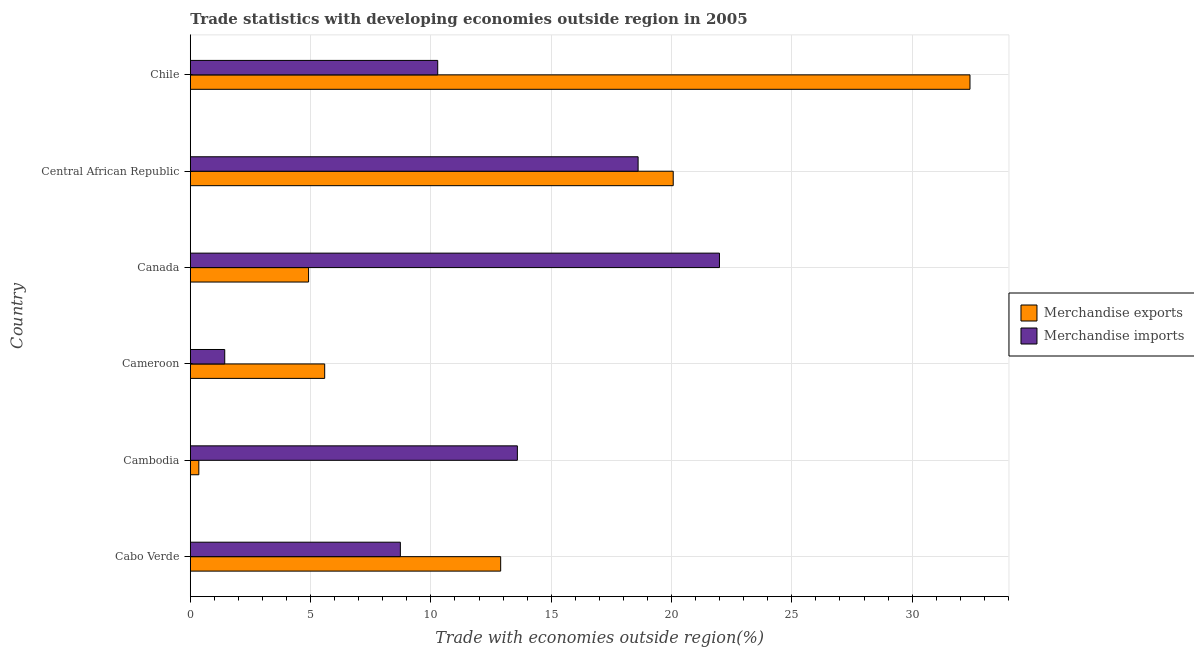How many different coloured bars are there?
Offer a very short reply. 2. How many groups of bars are there?
Offer a very short reply. 6. Are the number of bars per tick equal to the number of legend labels?
Ensure brevity in your answer.  Yes. Are the number of bars on each tick of the Y-axis equal?
Make the answer very short. Yes. How many bars are there on the 3rd tick from the top?
Offer a very short reply. 2. How many bars are there on the 4th tick from the bottom?
Provide a succinct answer. 2. What is the label of the 6th group of bars from the top?
Your response must be concise. Cabo Verde. What is the merchandise exports in Canada?
Offer a very short reply. 4.92. Across all countries, what is the maximum merchandise exports?
Provide a short and direct response. 32.4. Across all countries, what is the minimum merchandise exports?
Provide a short and direct response. 0.35. In which country was the merchandise imports maximum?
Offer a very short reply. Canada. In which country was the merchandise imports minimum?
Provide a succinct answer. Cameroon. What is the total merchandise imports in the graph?
Keep it short and to the point. 74.64. What is the difference between the merchandise exports in Cameroon and that in Chile?
Provide a short and direct response. -26.82. What is the difference between the merchandise imports in Canada and the merchandise exports in Cabo Verde?
Provide a succinct answer. 9.09. What is the average merchandise exports per country?
Provide a short and direct response. 12.7. What is the difference between the merchandise imports and merchandise exports in Canada?
Provide a short and direct response. 17.07. What is the ratio of the merchandise exports in Cambodia to that in Canada?
Your answer should be compact. 0.07. Is the merchandise imports in Canada less than that in Chile?
Ensure brevity in your answer.  No. What is the difference between the highest and the second highest merchandise imports?
Your answer should be compact. 3.38. What is the difference between the highest and the lowest merchandise exports?
Offer a very short reply. 32.05. In how many countries, is the merchandise imports greater than the average merchandise imports taken over all countries?
Ensure brevity in your answer.  3. What does the 1st bar from the bottom in Cambodia represents?
Ensure brevity in your answer.  Merchandise exports. Are all the bars in the graph horizontal?
Give a very brief answer. Yes. How many countries are there in the graph?
Your response must be concise. 6. Are the values on the major ticks of X-axis written in scientific E-notation?
Offer a very short reply. No. Does the graph contain any zero values?
Provide a short and direct response. No. How are the legend labels stacked?
Your answer should be very brief. Vertical. What is the title of the graph?
Offer a very short reply. Trade statistics with developing economies outside region in 2005. Does "Male population" appear as one of the legend labels in the graph?
Your answer should be very brief. No. What is the label or title of the X-axis?
Your answer should be compact. Trade with economies outside region(%). What is the Trade with economies outside region(%) of Merchandise exports in Cabo Verde?
Give a very brief answer. 12.9. What is the Trade with economies outside region(%) in Merchandise imports in Cabo Verde?
Your answer should be very brief. 8.73. What is the Trade with economies outside region(%) of Merchandise exports in Cambodia?
Your answer should be very brief. 0.35. What is the Trade with economies outside region(%) of Merchandise imports in Cambodia?
Offer a terse response. 13.59. What is the Trade with economies outside region(%) in Merchandise exports in Cameroon?
Your answer should be compact. 5.59. What is the Trade with economies outside region(%) in Merchandise imports in Cameroon?
Offer a very short reply. 1.43. What is the Trade with economies outside region(%) in Merchandise exports in Canada?
Ensure brevity in your answer.  4.92. What is the Trade with economies outside region(%) of Merchandise imports in Canada?
Ensure brevity in your answer.  21.99. What is the Trade with economies outside region(%) in Merchandise exports in Central African Republic?
Your answer should be very brief. 20.07. What is the Trade with economies outside region(%) in Merchandise imports in Central African Republic?
Your response must be concise. 18.61. What is the Trade with economies outside region(%) of Merchandise exports in Chile?
Your response must be concise. 32.4. What is the Trade with economies outside region(%) in Merchandise imports in Chile?
Provide a succinct answer. 10.28. Across all countries, what is the maximum Trade with economies outside region(%) in Merchandise exports?
Offer a terse response. 32.4. Across all countries, what is the maximum Trade with economies outside region(%) of Merchandise imports?
Your answer should be compact. 21.99. Across all countries, what is the minimum Trade with economies outside region(%) of Merchandise exports?
Your response must be concise. 0.35. Across all countries, what is the minimum Trade with economies outside region(%) of Merchandise imports?
Offer a very short reply. 1.43. What is the total Trade with economies outside region(%) of Merchandise exports in the graph?
Offer a very short reply. 76.23. What is the total Trade with economies outside region(%) in Merchandise imports in the graph?
Ensure brevity in your answer.  74.64. What is the difference between the Trade with economies outside region(%) of Merchandise exports in Cabo Verde and that in Cambodia?
Offer a terse response. 12.54. What is the difference between the Trade with economies outside region(%) of Merchandise imports in Cabo Verde and that in Cambodia?
Your answer should be very brief. -4.86. What is the difference between the Trade with economies outside region(%) in Merchandise exports in Cabo Verde and that in Cameroon?
Your answer should be very brief. 7.31. What is the difference between the Trade with economies outside region(%) in Merchandise imports in Cabo Verde and that in Cameroon?
Offer a very short reply. 7.3. What is the difference between the Trade with economies outside region(%) of Merchandise exports in Cabo Verde and that in Canada?
Your answer should be compact. 7.98. What is the difference between the Trade with economies outside region(%) in Merchandise imports in Cabo Verde and that in Canada?
Offer a very short reply. -13.26. What is the difference between the Trade with economies outside region(%) of Merchandise exports in Cabo Verde and that in Central African Republic?
Provide a short and direct response. -7.17. What is the difference between the Trade with economies outside region(%) of Merchandise imports in Cabo Verde and that in Central African Republic?
Your answer should be very brief. -9.88. What is the difference between the Trade with economies outside region(%) in Merchandise exports in Cabo Verde and that in Chile?
Provide a succinct answer. -19.5. What is the difference between the Trade with economies outside region(%) in Merchandise imports in Cabo Verde and that in Chile?
Provide a succinct answer. -1.55. What is the difference between the Trade with economies outside region(%) in Merchandise exports in Cambodia and that in Cameroon?
Offer a very short reply. -5.23. What is the difference between the Trade with economies outside region(%) of Merchandise imports in Cambodia and that in Cameroon?
Your response must be concise. 12.16. What is the difference between the Trade with economies outside region(%) in Merchandise exports in Cambodia and that in Canada?
Give a very brief answer. -4.56. What is the difference between the Trade with economies outside region(%) of Merchandise imports in Cambodia and that in Canada?
Your answer should be compact. -8.4. What is the difference between the Trade with economies outside region(%) in Merchandise exports in Cambodia and that in Central African Republic?
Your answer should be compact. -19.72. What is the difference between the Trade with economies outside region(%) in Merchandise imports in Cambodia and that in Central African Republic?
Offer a very short reply. -5.02. What is the difference between the Trade with economies outside region(%) in Merchandise exports in Cambodia and that in Chile?
Offer a very short reply. -32.05. What is the difference between the Trade with economies outside region(%) of Merchandise imports in Cambodia and that in Chile?
Offer a very short reply. 3.31. What is the difference between the Trade with economies outside region(%) of Merchandise exports in Cameroon and that in Canada?
Offer a terse response. 0.67. What is the difference between the Trade with economies outside region(%) in Merchandise imports in Cameroon and that in Canada?
Your response must be concise. -20.56. What is the difference between the Trade with economies outside region(%) in Merchandise exports in Cameroon and that in Central African Republic?
Make the answer very short. -14.48. What is the difference between the Trade with economies outside region(%) of Merchandise imports in Cameroon and that in Central African Republic?
Offer a terse response. -17.18. What is the difference between the Trade with economies outside region(%) in Merchandise exports in Cameroon and that in Chile?
Keep it short and to the point. -26.82. What is the difference between the Trade with economies outside region(%) of Merchandise imports in Cameroon and that in Chile?
Your response must be concise. -8.85. What is the difference between the Trade with economies outside region(%) of Merchandise exports in Canada and that in Central African Republic?
Keep it short and to the point. -15.15. What is the difference between the Trade with economies outside region(%) in Merchandise imports in Canada and that in Central African Republic?
Offer a very short reply. 3.38. What is the difference between the Trade with economies outside region(%) of Merchandise exports in Canada and that in Chile?
Your response must be concise. -27.49. What is the difference between the Trade with economies outside region(%) of Merchandise imports in Canada and that in Chile?
Your answer should be compact. 11.71. What is the difference between the Trade with economies outside region(%) in Merchandise exports in Central African Republic and that in Chile?
Offer a very short reply. -12.33. What is the difference between the Trade with economies outside region(%) of Merchandise imports in Central African Republic and that in Chile?
Make the answer very short. 8.33. What is the difference between the Trade with economies outside region(%) in Merchandise exports in Cabo Verde and the Trade with economies outside region(%) in Merchandise imports in Cambodia?
Provide a succinct answer. -0.69. What is the difference between the Trade with economies outside region(%) in Merchandise exports in Cabo Verde and the Trade with economies outside region(%) in Merchandise imports in Cameroon?
Your answer should be very brief. 11.47. What is the difference between the Trade with economies outside region(%) in Merchandise exports in Cabo Verde and the Trade with economies outside region(%) in Merchandise imports in Canada?
Ensure brevity in your answer.  -9.09. What is the difference between the Trade with economies outside region(%) of Merchandise exports in Cabo Verde and the Trade with economies outside region(%) of Merchandise imports in Central African Republic?
Make the answer very short. -5.71. What is the difference between the Trade with economies outside region(%) in Merchandise exports in Cabo Verde and the Trade with economies outside region(%) in Merchandise imports in Chile?
Offer a terse response. 2.62. What is the difference between the Trade with economies outside region(%) in Merchandise exports in Cambodia and the Trade with economies outside region(%) in Merchandise imports in Cameroon?
Keep it short and to the point. -1.08. What is the difference between the Trade with economies outside region(%) in Merchandise exports in Cambodia and the Trade with economies outside region(%) in Merchandise imports in Canada?
Your answer should be compact. -21.64. What is the difference between the Trade with economies outside region(%) in Merchandise exports in Cambodia and the Trade with economies outside region(%) in Merchandise imports in Central African Republic?
Provide a succinct answer. -18.26. What is the difference between the Trade with economies outside region(%) of Merchandise exports in Cambodia and the Trade with economies outside region(%) of Merchandise imports in Chile?
Ensure brevity in your answer.  -9.93. What is the difference between the Trade with economies outside region(%) in Merchandise exports in Cameroon and the Trade with economies outside region(%) in Merchandise imports in Canada?
Provide a short and direct response. -16.41. What is the difference between the Trade with economies outside region(%) of Merchandise exports in Cameroon and the Trade with economies outside region(%) of Merchandise imports in Central African Republic?
Keep it short and to the point. -13.03. What is the difference between the Trade with economies outside region(%) in Merchandise exports in Cameroon and the Trade with economies outside region(%) in Merchandise imports in Chile?
Your answer should be compact. -4.7. What is the difference between the Trade with economies outside region(%) in Merchandise exports in Canada and the Trade with economies outside region(%) in Merchandise imports in Central African Republic?
Provide a short and direct response. -13.69. What is the difference between the Trade with economies outside region(%) in Merchandise exports in Canada and the Trade with economies outside region(%) in Merchandise imports in Chile?
Ensure brevity in your answer.  -5.37. What is the difference between the Trade with economies outside region(%) of Merchandise exports in Central African Republic and the Trade with economies outside region(%) of Merchandise imports in Chile?
Offer a very short reply. 9.79. What is the average Trade with economies outside region(%) of Merchandise exports per country?
Your answer should be very brief. 12.7. What is the average Trade with economies outside region(%) of Merchandise imports per country?
Keep it short and to the point. 12.44. What is the difference between the Trade with economies outside region(%) in Merchandise exports and Trade with economies outside region(%) in Merchandise imports in Cabo Verde?
Keep it short and to the point. 4.17. What is the difference between the Trade with economies outside region(%) in Merchandise exports and Trade with economies outside region(%) in Merchandise imports in Cambodia?
Ensure brevity in your answer.  -13.24. What is the difference between the Trade with economies outside region(%) in Merchandise exports and Trade with economies outside region(%) in Merchandise imports in Cameroon?
Your answer should be very brief. 4.15. What is the difference between the Trade with economies outside region(%) in Merchandise exports and Trade with economies outside region(%) in Merchandise imports in Canada?
Offer a terse response. -17.08. What is the difference between the Trade with economies outside region(%) of Merchandise exports and Trade with economies outside region(%) of Merchandise imports in Central African Republic?
Your answer should be very brief. 1.46. What is the difference between the Trade with economies outside region(%) of Merchandise exports and Trade with economies outside region(%) of Merchandise imports in Chile?
Your answer should be compact. 22.12. What is the ratio of the Trade with economies outside region(%) of Merchandise exports in Cabo Verde to that in Cambodia?
Offer a very short reply. 36.38. What is the ratio of the Trade with economies outside region(%) of Merchandise imports in Cabo Verde to that in Cambodia?
Provide a short and direct response. 0.64. What is the ratio of the Trade with economies outside region(%) in Merchandise exports in Cabo Verde to that in Cameroon?
Give a very brief answer. 2.31. What is the ratio of the Trade with economies outside region(%) in Merchandise imports in Cabo Verde to that in Cameroon?
Offer a very short reply. 6.1. What is the ratio of the Trade with economies outside region(%) of Merchandise exports in Cabo Verde to that in Canada?
Your answer should be compact. 2.62. What is the ratio of the Trade with economies outside region(%) of Merchandise imports in Cabo Verde to that in Canada?
Make the answer very short. 0.4. What is the ratio of the Trade with economies outside region(%) in Merchandise exports in Cabo Verde to that in Central African Republic?
Your answer should be very brief. 0.64. What is the ratio of the Trade with economies outside region(%) in Merchandise imports in Cabo Verde to that in Central African Republic?
Provide a succinct answer. 0.47. What is the ratio of the Trade with economies outside region(%) in Merchandise exports in Cabo Verde to that in Chile?
Make the answer very short. 0.4. What is the ratio of the Trade with economies outside region(%) of Merchandise imports in Cabo Verde to that in Chile?
Offer a very short reply. 0.85. What is the ratio of the Trade with economies outside region(%) of Merchandise exports in Cambodia to that in Cameroon?
Provide a short and direct response. 0.06. What is the ratio of the Trade with economies outside region(%) in Merchandise imports in Cambodia to that in Cameroon?
Keep it short and to the point. 9.5. What is the ratio of the Trade with economies outside region(%) in Merchandise exports in Cambodia to that in Canada?
Your response must be concise. 0.07. What is the ratio of the Trade with economies outside region(%) in Merchandise imports in Cambodia to that in Canada?
Provide a short and direct response. 0.62. What is the ratio of the Trade with economies outside region(%) of Merchandise exports in Cambodia to that in Central African Republic?
Offer a very short reply. 0.02. What is the ratio of the Trade with economies outside region(%) in Merchandise imports in Cambodia to that in Central African Republic?
Provide a succinct answer. 0.73. What is the ratio of the Trade with economies outside region(%) in Merchandise exports in Cambodia to that in Chile?
Offer a very short reply. 0.01. What is the ratio of the Trade with economies outside region(%) in Merchandise imports in Cambodia to that in Chile?
Offer a very short reply. 1.32. What is the ratio of the Trade with economies outside region(%) in Merchandise exports in Cameroon to that in Canada?
Provide a succinct answer. 1.14. What is the ratio of the Trade with economies outside region(%) in Merchandise imports in Cameroon to that in Canada?
Make the answer very short. 0.07. What is the ratio of the Trade with economies outside region(%) of Merchandise exports in Cameroon to that in Central African Republic?
Provide a succinct answer. 0.28. What is the ratio of the Trade with economies outside region(%) in Merchandise imports in Cameroon to that in Central African Republic?
Give a very brief answer. 0.08. What is the ratio of the Trade with economies outside region(%) of Merchandise exports in Cameroon to that in Chile?
Provide a short and direct response. 0.17. What is the ratio of the Trade with economies outside region(%) of Merchandise imports in Cameroon to that in Chile?
Offer a terse response. 0.14. What is the ratio of the Trade with economies outside region(%) of Merchandise exports in Canada to that in Central African Republic?
Your response must be concise. 0.24. What is the ratio of the Trade with economies outside region(%) of Merchandise imports in Canada to that in Central African Republic?
Your response must be concise. 1.18. What is the ratio of the Trade with economies outside region(%) of Merchandise exports in Canada to that in Chile?
Provide a succinct answer. 0.15. What is the ratio of the Trade with economies outside region(%) of Merchandise imports in Canada to that in Chile?
Offer a very short reply. 2.14. What is the ratio of the Trade with economies outside region(%) of Merchandise exports in Central African Republic to that in Chile?
Make the answer very short. 0.62. What is the ratio of the Trade with economies outside region(%) in Merchandise imports in Central African Republic to that in Chile?
Provide a short and direct response. 1.81. What is the difference between the highest and the second highest Trade with economies outside region(%) in Merchandise exports?
Make the answer very short. 12.33. What is the difference between the highest and the second highest Trade with economies outside region(%) of Merchandise imports?
Provide a short and direct response. 3.38. What is the difference between the highest and the lowest Trade with economies outside region(%) in Merchandise exports?
Your response must be concise. 32.05. What is the difference between the highest and the lowest Trade with economies outside region(%) in Merchandise imports?
Your response must be concise. 20.56. 